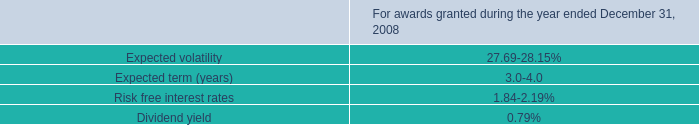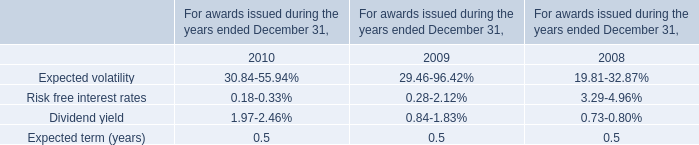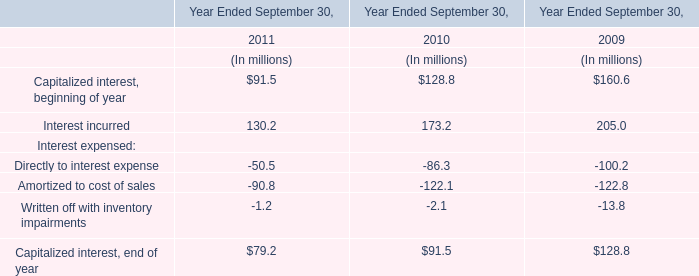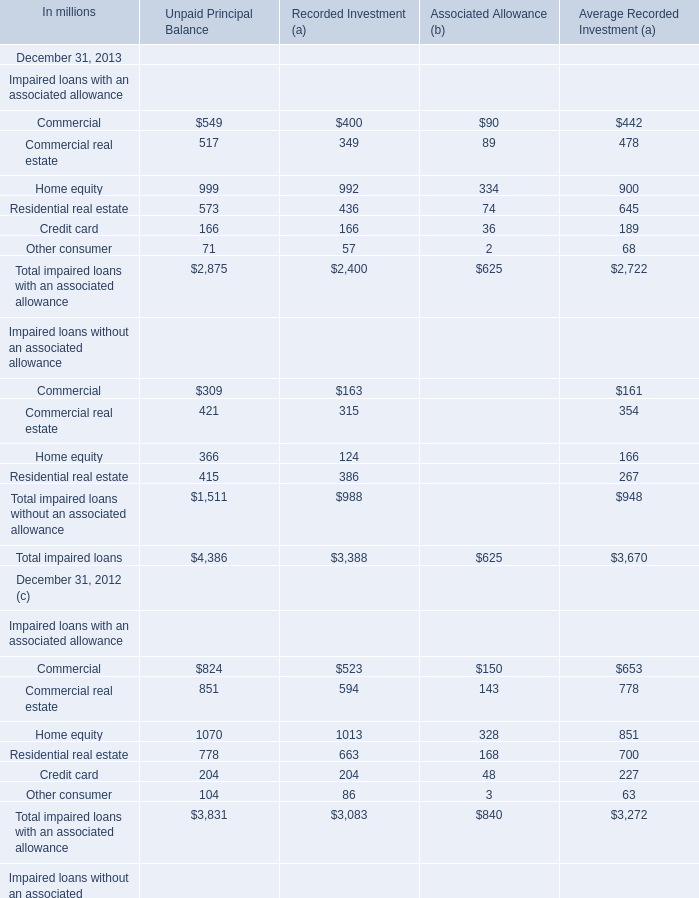What's the greatest value of Impaired loans with an associated allowance for unpaid principal balance in 2013? 
Answer: Home equity. 